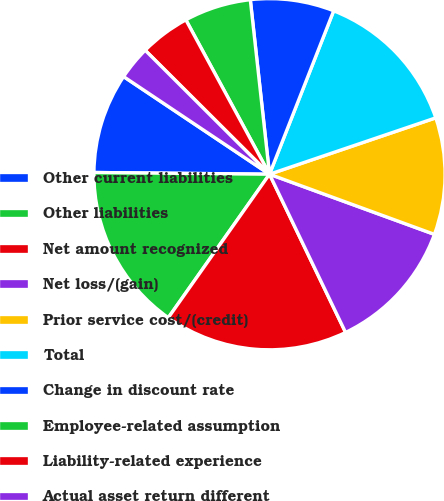Convert chart. <chart><loc_0><loc_0><loc_500><loc_500><pie_chart><fcel>Other current liabilities<fcel>Other liabilities<fcel>Net amount recognized<fcel>Net loss/(gain)<fcel>Prior service cost/(credit)<fcel>Total<fcel>Change in discount rate<fcel>Employee-related assumption<fcel>Liability-related experience<fcel>Actual asset return different<nl><fcel>9.23%<fcel>15.38%<fcel>16.91%<fcel>12.3%<fcel>10.77%<fcel>13.84%<fcel>7.7%<fcel>6.16%<fcel>4.62%<fcel>3.09%<nl></chart> 